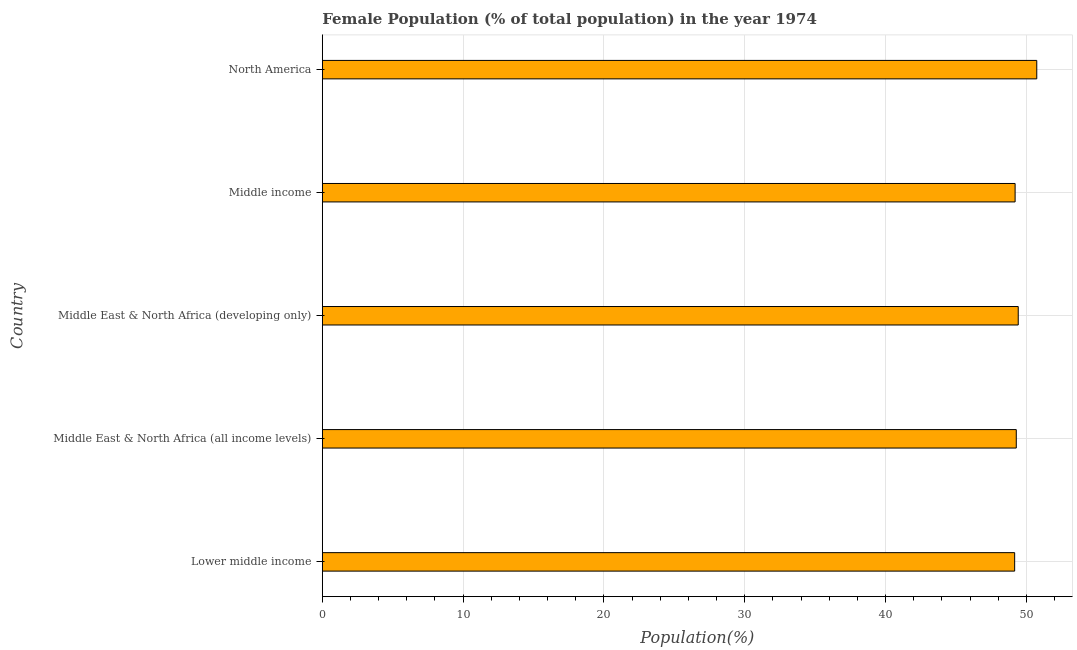Does the graph contain grids?
Give a very brief answer. Yes. What is the title of the graph?
Provide a succinct answer. Female Population (% of total population) in the year 1974. What is the label or title of the X-axis?
Provide a succinct answer. Population(%). What is the female population in Middle East & North Africa (developing only)?
Your answer should be very brief. 49.42. Across all countries, what is the maximum female population?
Your answer should be very brief. 50.73. Across all countries, what is the minimum female population?
Your answer should be very brief. 49.16. In which country was the female population minimum?
Provide a succinct answer. Lower middle income. What is the sum of the female population?
Provide a short and direct response. 247.79. What is the difference between the female population in Middle East & North Africa (all income levels) and Middle East & North Africa (developing only)?
Your answer should be very brief. -0.14. What is the average female population per country?
Your answer should be very brief. 49.56. What is the median female population?
Keep it short and to the point. 49.28. Is the female population in Middle East & North Africa (developing only) less than that in North America?
Your answer should be compact. Yes. What is the difference between the highest and the second highest female population?
Ensure brevity in your answer.  1.32. Is the sum of the female population in Middle East & North Africa (all income levels) and North America greater than the maximum female population across all countries?
Provide a succinct answer. Yes. What is the difference between the highest and the lowest female population?
Your answer should be compact. 1.57. How many bars are there?
Your answer should be very brief. 5. How many countries are there in the graph?
Ensure brevity in your answer.  5. What is the difference between two consecutive major ticks on the X-axis?
Your response must be concise. 10. Are the values on the major ticks of X-axis written in scientific E-notation?
Your answer should be very brief. No. What is the Population(%) of Lower middle income?
Ensure brevity in your answer.  49.16. What is the Population(%) in Middle East & North Africa (all income levels)?
Your response must be concise. 49.28. What is the Population(%) in Middle East & North Africa (developing only)?
Your answer should be very brief. 49.42. What is the Population(%) in Middle income?
Provide a short and direct response. 49.2. What is the Population(%) of North America?
Offer a very short reply. 50.73. What is the difference between the Population(%) in Lower middle income and Middle East & North Africa (all income levels)?
Provide a succinct answer. -0.12. What is the difference between the Population(%) in Lower middle income and Middle East & North Africa (developing only)?
Give a very brief answer. -0.25. What is the difference between the Population(%) in Lower middle income and Middle income?
Offer a terse response. -0.03. What is the difference between the Population(%) in Lower middle income and North America?
Keep it short and to the point. -1.57. What is the difference between the Population(%) in Middle East & North Africa (all income levels) and Middle East & North Africa (developing only)?
Provide a succinct answer. -0.14. What is the difference between the Population(%) in Middle East & North Africa (all income levels) and Middle income?
Ensure brevity in your answer.  0.08. What is the difference between the Population(%) in Middle East & North Africa (all income levels) and North America?
Your answer should be compact. -1.45. What is the difference between the Population(%) in Middle East & North Africa (developing only) and Middle income?
Offer a terse response. 0.22. What is the difference between the Population(%) in Middle East & North Africa (developing only) and North America?
Your response must be concise. -1.32. What is the difference between the Population(%) in Middle income and North America?
Your answer should be very brief. -1.54. What is the ratio of the Population(%) in Lower middle income to that in Middle East & North Africa (all income levels)?
Your answer should be compact. 1. What is the ratio of the Population(%) in Lower middle income to that in North America?
Your answer should be compact. 0.97. What is the ratio of the Population(%) in Middle East & North Africa (all income levels) to that in North America?
Offer a terse response. 0.97. What is the ratio of the Population(%) in Middle East & North Africa (developing only) to that in North America?
Make the answer very short. 0.97. What is the ratio of the Population(%) in Middle income to that in North America?
Offer a terse response. 0.97. 